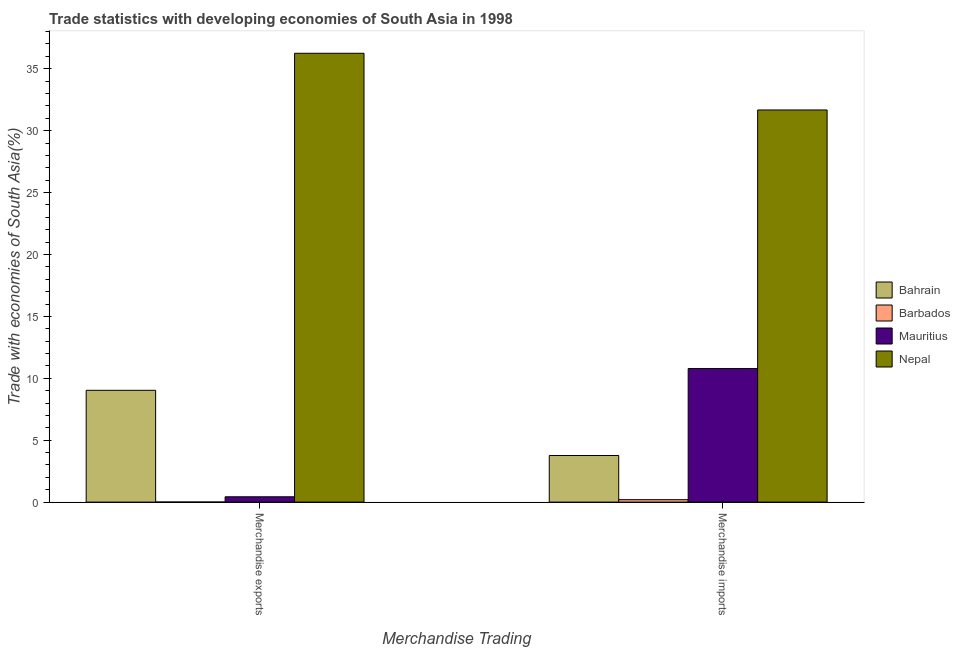How many groups of bars are there?
Ensure brevity in your answer.  2. Are the number of bars on each tick of the X-axis equal?
Ensure brevity in your answer.  Yes. How many bars are there on the 2nd tick from the right?
Offer a terse response. 4. What is the merchandise exports in Bahrain?
Make the answer very short. 9.03. Across all countries, what is the maximum merchandise imports?
Your answer should be very brief. 31.67. Across all countries, what is the minimum merchandise imports?
Your answer should be very brief. 0.2. In which country was the merchandise exports maximum?
Offer a very short reply. Nepal. In which country was the merchandise imports minimum?
Offer a terse response. Barbados. What is the total merchandise imports in the graph?
Your answer should be very brief. 46.42. What is the difference between the merchandise imports in Barbados and that in Nepal?
Keep it short and to the point. -31.47. What is the difference between the merchandise exports in Nepal and the merchandise imports in Bahrain?
Make the answer very short. 32.48. What is the average merchandise exports per country?
Provide a succinct answer. 11.43. What is the difference between the merchandise exports and merchandise imports in Mauritius?
Your answer should be compact. -10.36. In how many countries, is the merchandise exports greater than 30 %?
Give a very brief answer. 1. What is the ratio of the merchandise exports in Bahrain to that in Nepal?
Give a very brief answer. 0.25. What does the 3rd bar from the left in Merchandise imports represents?
Offer a very short reply. Mauritius. What does the 3rd bar from the right in Merchandise imports represents?
Offer a terse response. Barbados. Are all the bars in the graph horizontal?
Make the answer very short. No. How many countries are there in the graph?
Offer a terse response. 4. Does the graph contain any zero values?
Your answer should be very brief. No. Does the graph contain grids?
Provide a short and direct response. No. How are the legend labels stacked?
Ensure brevity in your answer.  Vertical. What is the title of the graph?
Provide a short and direct response. Trade statistics with developing economies of South Asia in 1998. Does "Puerto Rico" appear as one of the legend labels in the graph?
Ensure brevity in your answer.  No. What is the label or title of the X-axis?
Keep it short and to the point. Merchandise Trading. What is the label or title of the Y-axis?
Your answer should be compact. Trade with economies of South Asia(%). What is the Trade with economies of South Asia(%) of Bahrain in Merchandise exports?
Your answer should be compact. 9.03. What is the Trade with economies of South Asia(%) of Barbados in Merchandise exports?
Your answer should be very brief. 0.01. What is the Trade with economies of South Asia(%) in Mauritius in Merchandise exports?
Keep it short and to the point. 0.43. What is the Trade with economies of South Asia(%) of Nepal in Merchandise exports?
Offer a terse response. 36.25. What is the Trade with economies of South Asia(%) in Bahrain in Merchandise imports?
Your answer should be compact. 3.76. What is the Trade with economies of South Asia(%) in Barbados in Merchandise imports?
Your answer should be very brief. 0.2. What is the Trade with economies of South Asia(%) in Mauritius in Merchandise imports?
Your answer should be very brief. 10.79. What is the Trade with economies of South Asia(%) of Nepal in Merchandise imports?
Keep it short and to the point. 31.67. Across all Merchandise Trading, what is the maximum Trade with economies of South Asia(%) in Bahrain?
Provide a short and direct response. 9.03. Across all Merchandise Trading, what is the maximum Trade with economies of South Asia(%) of Barbados?
Make the answer very short. 0.2. Across all Merchandise Trading, what is the maximum Trade with economies of South Asia(%) in Mauritius?
Offer a very short reply. 10.79. Across all Merchandise Trading, what is the maximum Trade with economies of South Asia(%) of Nepal?
Offer a terse response. 36.25. Across all Merchandise Trading, what is the minimum Trade with economies of South Asia(%) in Bahrain?
Your answer should be very brief. 3.76. Across all Merchandise Trading, what is the minimum Trade with economies of South Asia(%) in Barbados?
Ensure brevity in your answer.  0.01. Across all Merchandise Trading, what is the minimum Trade with economies of South Asia(%) in Mauritius?
Offer a very short reply. 0.43. Across all Merchandise Trading, what is the minimum Trade with economies of South Asia(%) in Nepal?
Your response must be concise. 31.67. What is the total Trade with economies of South Asia(%) of Bahrain in the graph?
Keep it short and to the point. 12.79. What is the total Trade with economies of South Asia(%) in Barbados in the graph?
Provide a succinct answer. 0.21. What is the total Trade with economies of South Asia(%) in Mauritius in the graph?
Make the answer very short. 11.22. What is the total Trade with economies of South Asia(%) of Nepal in the graph?
Give a very brief answer. 67.92. What is the difference between the Trade with economies of South Asia(%) of Bahrain in Merchandise exports and that in Merchandise imports?
Your response must be concise. 5.27. What is the difference between the Trade with economies of South Asia(%) in Barbados in Merchandise exports and that in Merchandise imports?
Keep it short and to the point. -0.19. What is the difference between the Trade with economies of South Asia(%) of Mauritius in Merchandise exports and that in Merchandise imports?
Your answer should be very brief. -10.36. What is the difference between the Trade with economies of South Asia(%) in Nepal in Merchandise exports and that in Merchandise imports?
Keep it short and to the point. 4.58. What is the difference between the Trade with economies of South Asia(%) of Bahrain in Merchandise exports and the Trade with economies of South Asia(%) of Barbados in Merchandise imports?
Your answer should be very brief. 8.83. What is the difference between the Trade with economies of South Asia(%) in Bahrain in Merchandise exports and the Trade with economies of South Asia(%) in Mauritius in Merchandise imports?
Provide a succinct answer. -1.76. What is the difference between the Trade with economies of South Asia(%) in Bahrain in Merchandise exports and the Trade with economies of South Asia(%) in Nepal in Merchandise imports?
Keep it short and to the point. -22.64. What is the difference between the Trade with economies of South Asia(%) in Barbados in Merchandise exports and the Trade with economies of South Asia(%) in Mauritius in Merchandise imports?
Provide a succinct answer. -10.78. What is the difference between the Trade with economies of South Asia(%) of Barbados in Merchandise exports and the Trade with economies of South Asia(%) of Nepal in Merchandise imports?
Offer a terse response. -31.66. What is the difference between the Trade with economies of South Asia(%) in Mauritius in Merchandise exports and the Trade with economies of South Asia(%) in Nepal in Merchandise imports?
Your response must be concise. -31.24. What is the average Trade with economies of South Asia(%) of Bahrain per Merchandise Trading?
Your response must be concise. 6.4. What is the average Trade with economies of South Asia(%) of Barbados per Merchandise Trading?
Offer a terse response. 0.1. What is the average Trade with economies of South Asia(%) in Mauritius per Merchandise Trading?
Your response must be concise. 5.61. What is the average Trade with economies of South Asia(%) in Nepal per Merchandise Trading?
Ensure brevity in your answer.  33.96. What is the difference between the Trade with economies of South Asia(%) in Bahrain and Trade with economies of South Asia(%) in Barbados in Merchandise exports?
Make the answer very short. 9.02. What is the difference between the Trade with economies of South Asia(%) of Bahrain and Trade with economies of South Asia(%) of Mauritius in Merchandise exports?
Provide a succinct answer. 8.6. What is the difference between the Trade with economies of South Asia(%) of Bahrain and Trade with economies of South Asia(%) of Nepal in Merchandise exports?
Ensure brevity in your answer.  -27.22. What is the difference between the Trade with economies of South Asia(%) of Barbados and Trade with economies of South Asia(%) of Mauritius in Merchandise exports?
Offer a terse response. -0.42. What is the difference between the Trade with economies of South Asia(%) of Barbados and Trade with economies of South Asia(%) of Nepal in Merchandise exports?
Your response must be concise. -36.24. What is the difference between the Trade with economies of South Asia(%) in Mauritius and Trade with economies of South Asia(%) in Nepal in Merchandise exports?
Offer a very short reply. -35.82. What is the difference between the Trade with economies of South Asia(%) in Bahrain and Trade with economies of South Asia(%) in Barbados in Merchandise imports?
Your answer should be compact. 3.57. What is the difference between the Trade with economies of South Asia(%) of Bahrain and Trade with economies of South Asia(%) of Mauritius in Merchandise imports?
Offer a very short reply. -7.02. What is the difference between the Trade with economies of South Asia(%) of Bahrain and Trade with economies of South Asia(%) of Nepal in Merchandise imports?
Give a very brief answer. -27.91. What is the difference between the Trade with economies of South Asia(%) of Barbados and Trade with economies of South Asia(%) of Mauritius in Merchandise imports?
Provide a short and direct response. -10.59. What is the difference between the Trade with economies of South Asia(%) in Barbados and Trade with economies of South Asia(%) in Nepal in Merchandise imports?
Make the answer very short. -31.47. What is the difference between the Trade with economies of South Asia(%) of Mauritius and Trade with economies of South Asia(%) of Nepal in Merchandise imports?
Provide a short and direct response. -20.88. What is the ratio of the Trade with economies of South Asia(%) in Bahrain in Merchandise exports to that in Merchandise imports?
Provide a succinct answer. 2.4. What is the ratio of the Trade with economies of South Asia(%) of Barbados in Merchandise exports to that in Merchandise imports?
Offer a very short reply. 0.04. What is the ratio of the Trade with economies of South Asia(%) of Mauritius in Merchandise exports to that in Merchandise imports?
Offer a very short reply. 0.04. What is the ratio of the Trade with economies of South Asia(%) of Nepal in Merchandise exports to that in Merchandise imports?
Your response must be concise. 1.14. What is the difference between the highest and the second highest Trade with economies of South Asia(%) in Bahrain?
Make the answer very short. 5.27. What is the difference between the highest and the second highest Trade with economies of South Asia(%) of Barbados?
Offer a terse response. 0.19. What is the difference between the highest and the second highest Trade with economies of South Asia(%) in Mauritius?
Your answer should be very brief. 10.36. What is the difference between the highest and the second highest Trade with economies of South Asia(%) of Nepal?
Make the answer very short. 4.58. What is the difference between the highest and the lowest Trade with economies of South Asia(%) in Bahrain?
Your response must be concise. 5.27. What is the difference between the highest and the lowest Trade with economies of South Asia(%) of Barbados?
Keep it short and to the point. 0.19. What is the difference between the highest and the lowest Trade with economies of South Asia(%) in Mauritius?
Make the answer very short. 10.36. What is the difference between the highest and the lowest Trade with economies of South Asia(%) in Nepal?
Give a very brief answer. 4.58. 